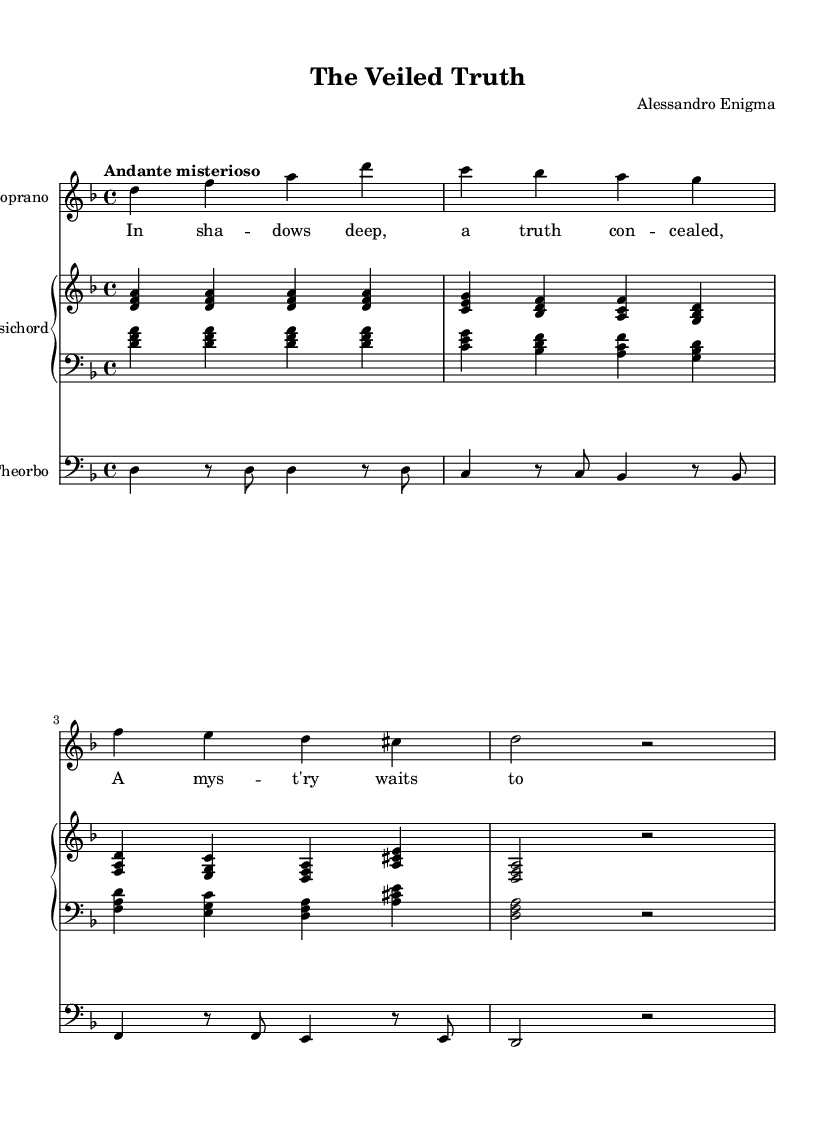What is the key signature of this music? The key signature is D minor, which has one flat (B flat). This can be determined by looking at the beginning of the staff where the key signature is indicated.
Answer: D minor What is the time signature of this music? The time signature is 4/4, which can be found at the beginning of the score next to the key signature. This indicates that there are four beats per measure, with the quarter note receiving one beat.
Answer: 4/4 What is the tempo marking of this piece? The tempo marking is "Andante misterioso," which is a directive for the speed and character of the music. It is written above the staff, indicating a moderately slow tempo with a mysterious feel.
Answer: Andante misterioso How many voices are present in this opera piece? There are two voices present: Soprano and Theorbo. The sheet music shows a staff for the Soprano and a separate staff for Theorbo, indicating the inclusion of both in the composition.
Answer: Two What instruments are included in the score? The instruments included are Soprano, Harpsichord, and Theorbo. This is indicated in the instrument names listed at the beginning of the respective staves in the score.
Answer: Soprano, Harpsichord, Theorbo What is the text theme of the soprano's lyrics? The theme of the soprano's lyrics revolves around mystery and concealment, as indicated by phrases such as "a truth concealed" and "a mystery waits." The lyrics suggest a narrative of hidden truths and revelations.
Answer: Mystery and concealment 